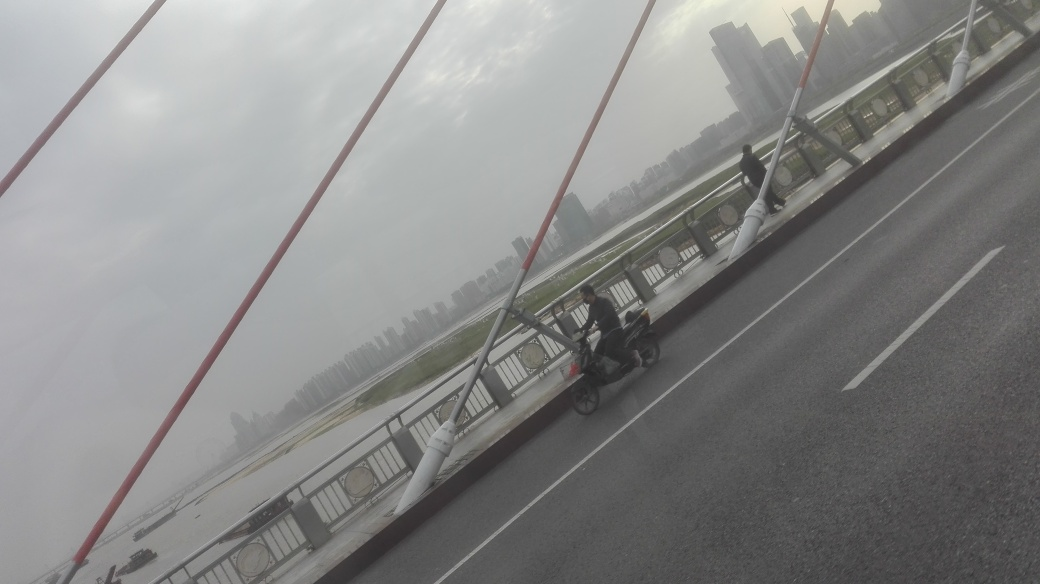Is the brightness of the image high? No, the brightness of the image is not high. It appears to be a cloudy and overcast day, which typically results in lower levels of light and a more subdued appearance. 